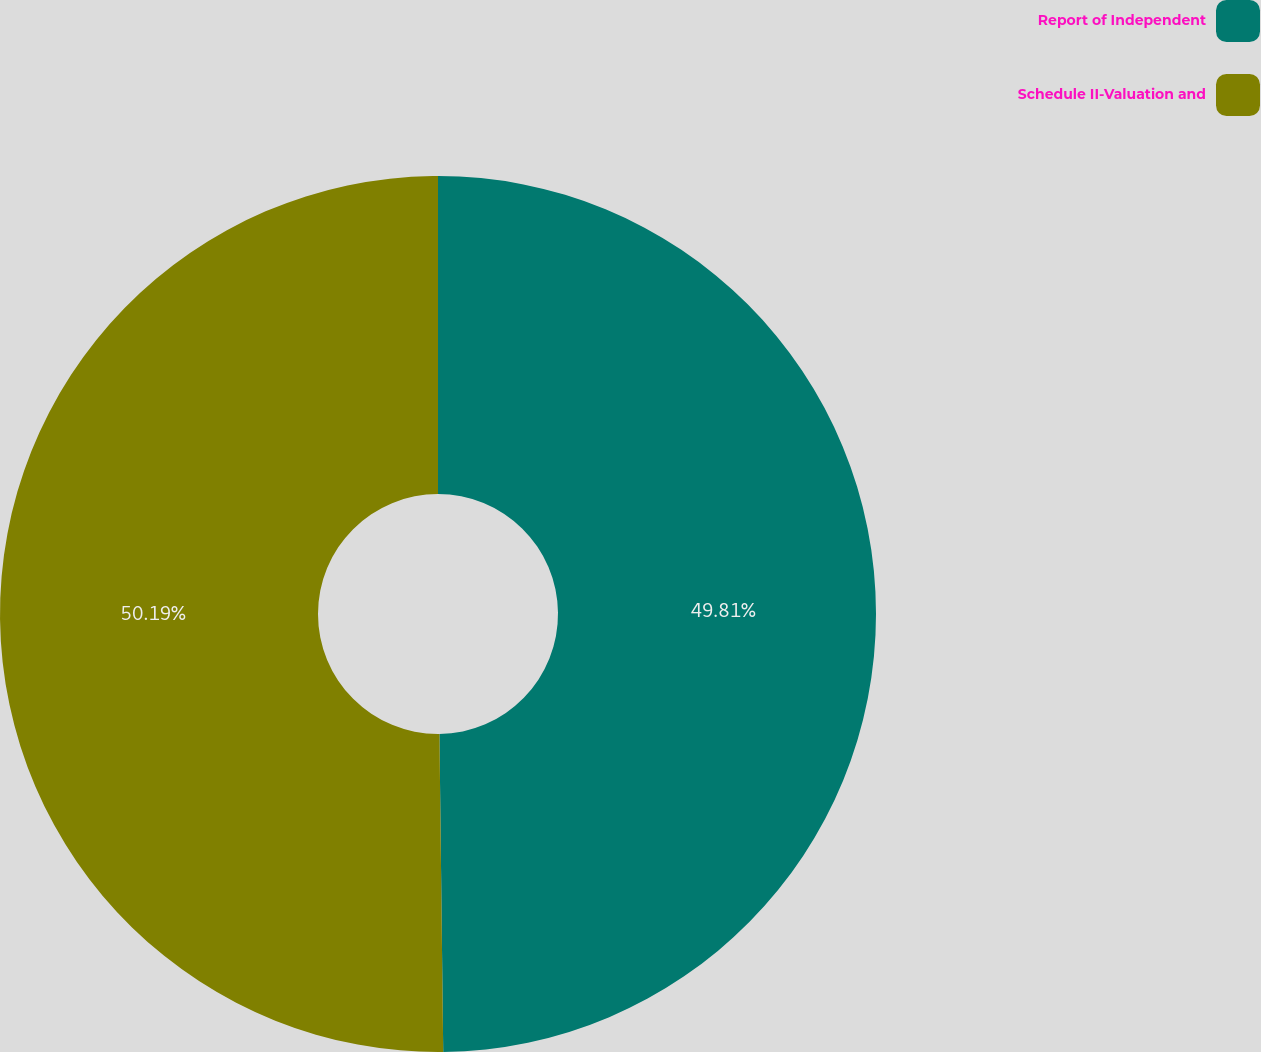Convert chart. <chart><loc_0><loc_0><loc_500><loc_500><pie_chart><fcel>Report of Independent<fcel>Schedule II-Valuation and<nl><fcel>49.81%<fcel>50.19%<nl></chart> 